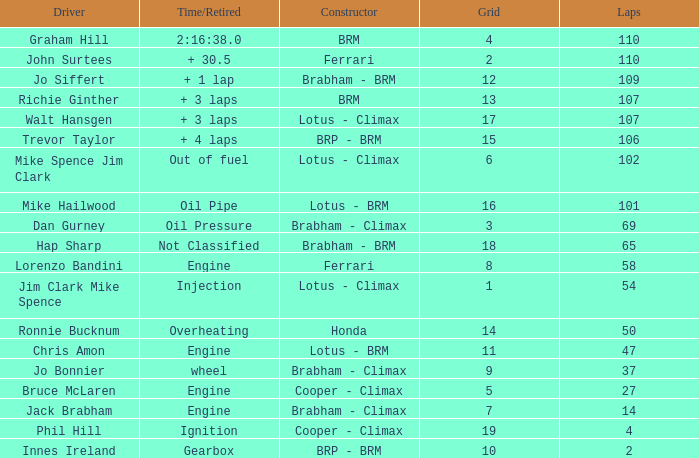What driver has a Time/Retired of 2:16:38.0? Graham Hill. 